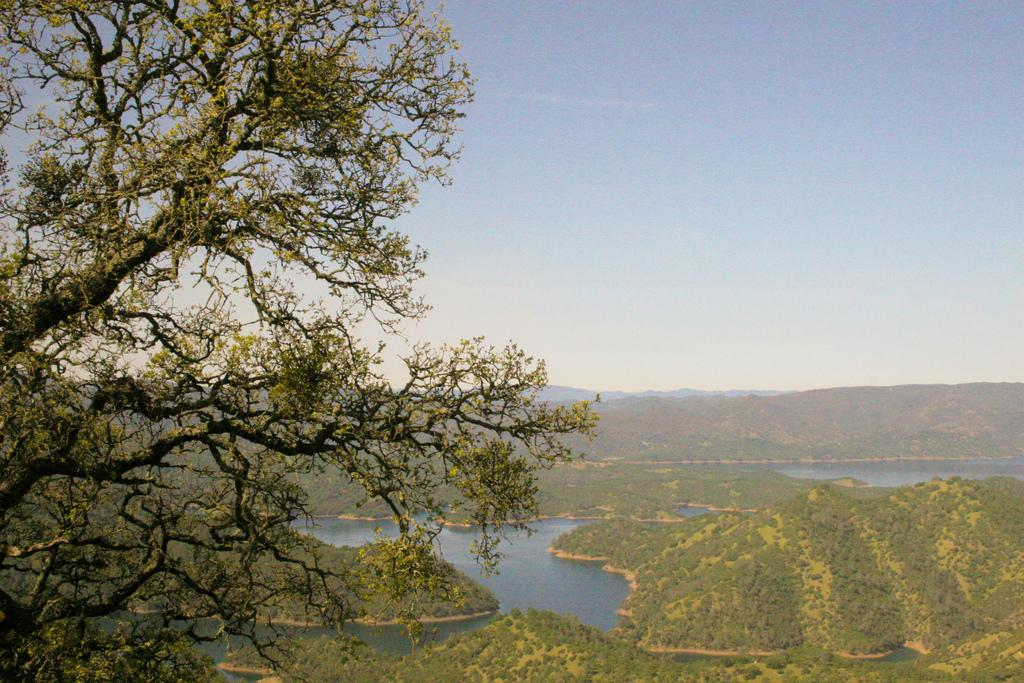What type of plant can be seen in the image? There is a tree in the image. What natural element is visible in the image? Water is visible in the image. What type of vegetation is present in the image? There is grass in the image. What is visible in the background of the image? The sky is visible in the image. Where is the clover located in the image? There is no clover present in the image. What type of food is being served in the lunchroom in the image? There is no lunchroom present in the image. 